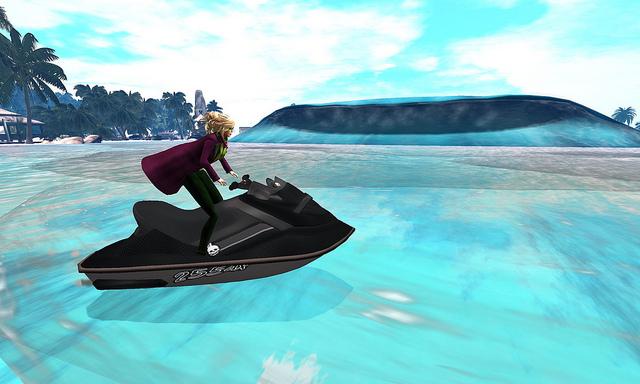Is this a virtual image?
Quick response, please. Yes. Is the woman holding onto the handles?
Be succinct. No. Is this real?
Quick response, please. No. 